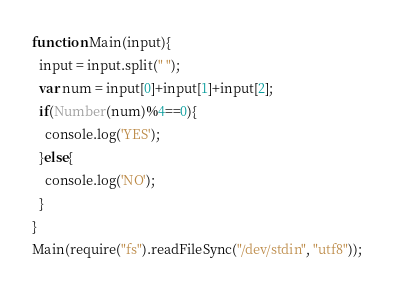Convert code to text. <code><loc_0><loc_0><loc_500><loc_500><_JavaScript_>function Main(input){
  input = input.split(" ");
  var num = input[0]+input[1]+input[2];
  if(Number(num)%4==0){
    console.log('YES');
  }else{
    console.log('NO');
  }
}
Main(require("fs").readFileSync("/dev/stdin", "utf8"));</code> 